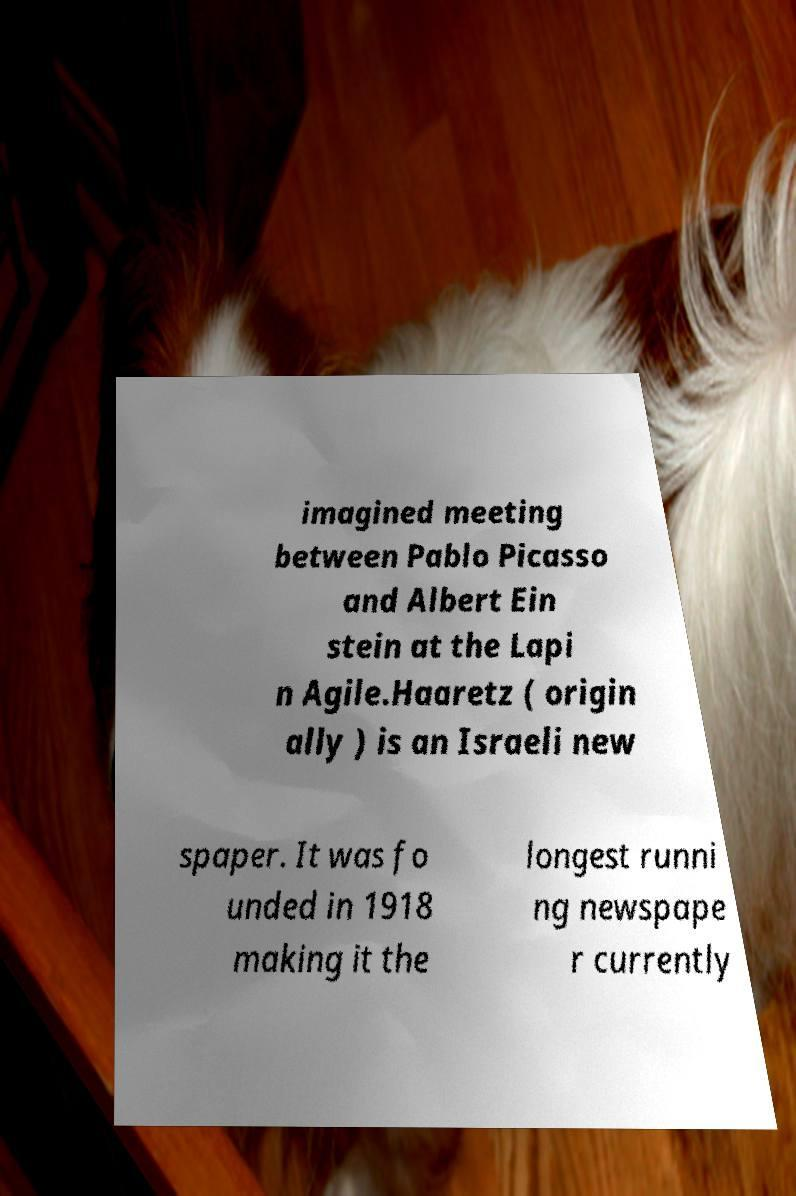I need the written content from this picture converted into text. Can you do that? imagined meeting between Pablo Picasso and Albert Ein stein at the Lapi n Agile.Haaretz ( origin ally ) is an Israeli new spaper. It was fo unded in 1918 making it the longest runni ng newspape r currently 